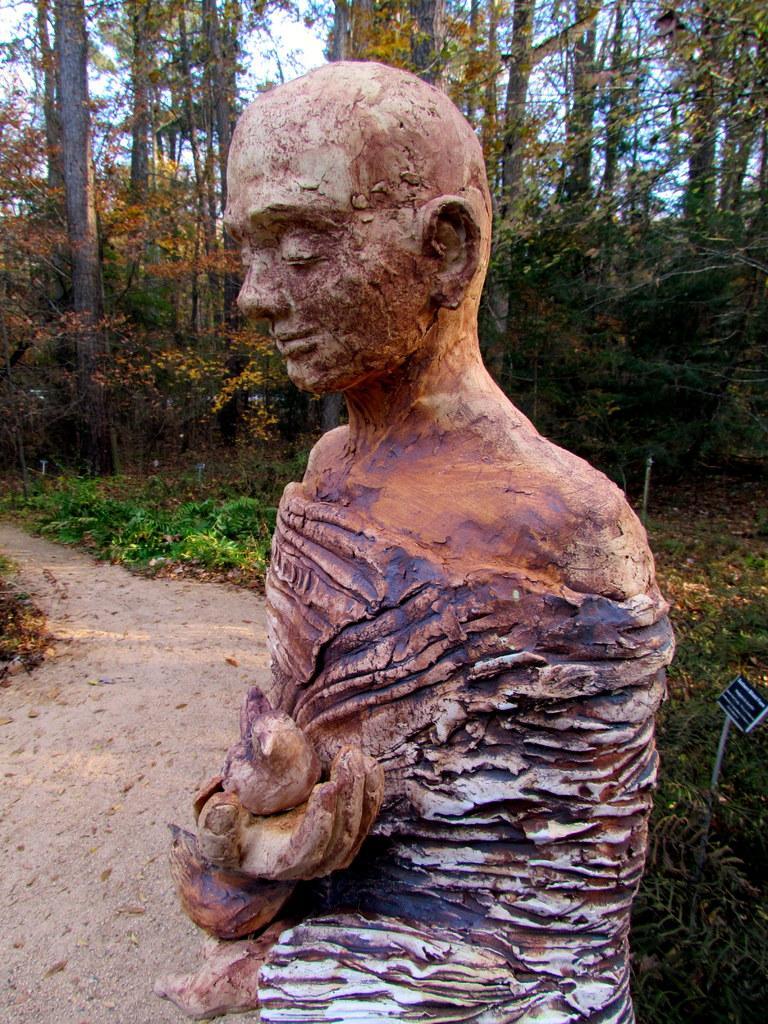How would you summarize this image in a sentence or two? In the picture i can see a statue of the person who is holding a bird in his hand and in the background i can see trees. 